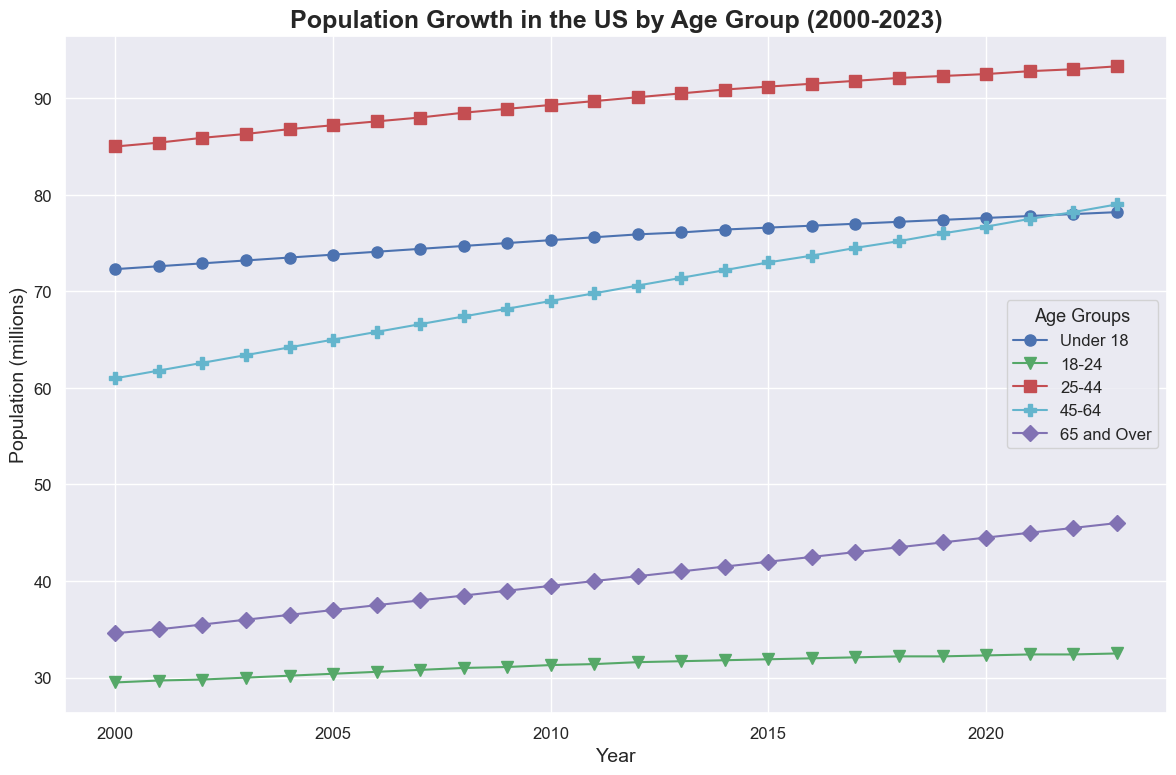What was the population of the 'Under 18' age group in 2005? Locate the point for the 'Under 18' age group and the year 2005 on the x-axis and read the corresponding y-axis value.
Answer: 73.8 million Which age group had the highest increase in population from 2000 to 2023? Identify the initial and final values for each age group on the y-axis, then calculate the difference for each group. Compare the resulting values.
Answer: 45-64 In which year did the population of the '18-24' age group reach 32 million? Locate the line representing the '18-24' age group, then find the year on the x-axis where it intersects the 32 million mark on the y-axis.
Answer: 2020 How much did the population of the '65 and Over' age group increase between 2010 and 2023? Find the population of the '65 and Over' age group for the years 2010 and 2023 and subtract the former from the latter.
Answer: 6.5 million Compare the population growth trends of the '25-44' and '45-64' age groups from 2005 to 2020. Which group grew more rapidly? Examine the slope of the lines representing both age groups between 2005 and 2020. The group with the steeper slope grew more rapidly.
Answer: 45-64 What is the average population of the '45-64' age group over the entire period? Sum the population values for the '45-64' age group from 2000 to 2023 and divide by the number of data points (24).
Answer: 70.9 million Which age group had the highest population in 2023? Look at the end point values for each age group in 2023 and identify the highest value.
Answer: 25-44 Identify the two age groups with the closest population figures in 2010. Check the population values for all age groups in 2010 and find the two groups with the smallest difference between their populations.
Answer: 18-24 and 65 and Over 